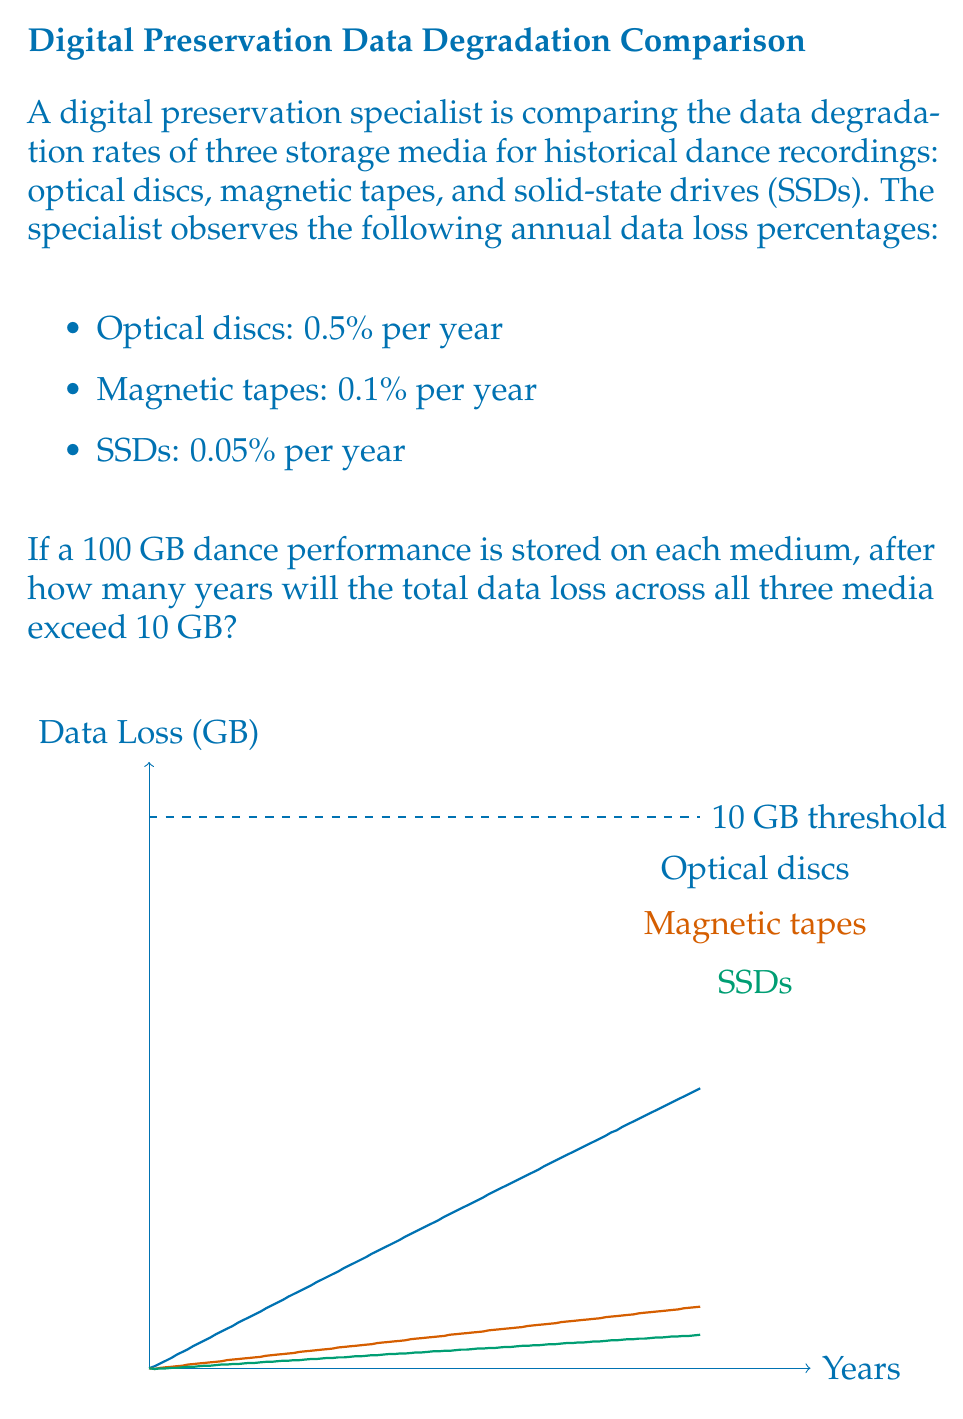Can you answer this question? To solve this problem, we need to calculate the cumulative data loss across all three media over time. Let's approach this step-by-step:

1) First, let's express the data remaining after $n$ years for each medium:

   Optical discs: $100 \cdot (1 - 0.005)^n$ GB
   Magnetic tapes: $100 \cdot (1 - 0.001)^n$ GB
   SSDs: $100 \cdot (1 - 0.0005)^n$ GB

2) The total data loss after $n$ years is:

   $L(n) = 300 - [100(1-0.005)^n + 100(1-0.001)^n + 100(1-0.0005)^n]$

3) We need to find $n$ where $L(n) > 10$ GB

4) This equation can't be solved algebraically, so we'll use a year-by-year calculation:

   Year 1: $L(1) = 300 - [99.5 + 99.9 + 99.95] = 0.65$ GB
   Year 2: $L(2) = 300 - [99.0025 + 99.8001 + 99.9000] = 1.2974$ GB
   ...
   Year 7: $L(7) = 300 - [96.5373 + 99.3014 + 99.6503] = 4.5110$ GB
   Year 8: $L(8) = 300 - [96.0546 + 99.2021 + 99.6004] = 5.1429$ GB
   Year 9: $L(9) = 300 - [95.5743 + 99.1030 + 99.5505] = 5.7722$ GB
   Year 10: $L(10) = 300 - [95.0964 + 99.0040 + 99.5006] = 6.3990$ GB
   ...
   Year 20: $L(20) = 300 - [90.4837 + 98.0199 + 99.0025] = 12.4939$ GB

5) We can see that the total data loss exceeds 10 GB after 20 years.
Answer: 20 years 